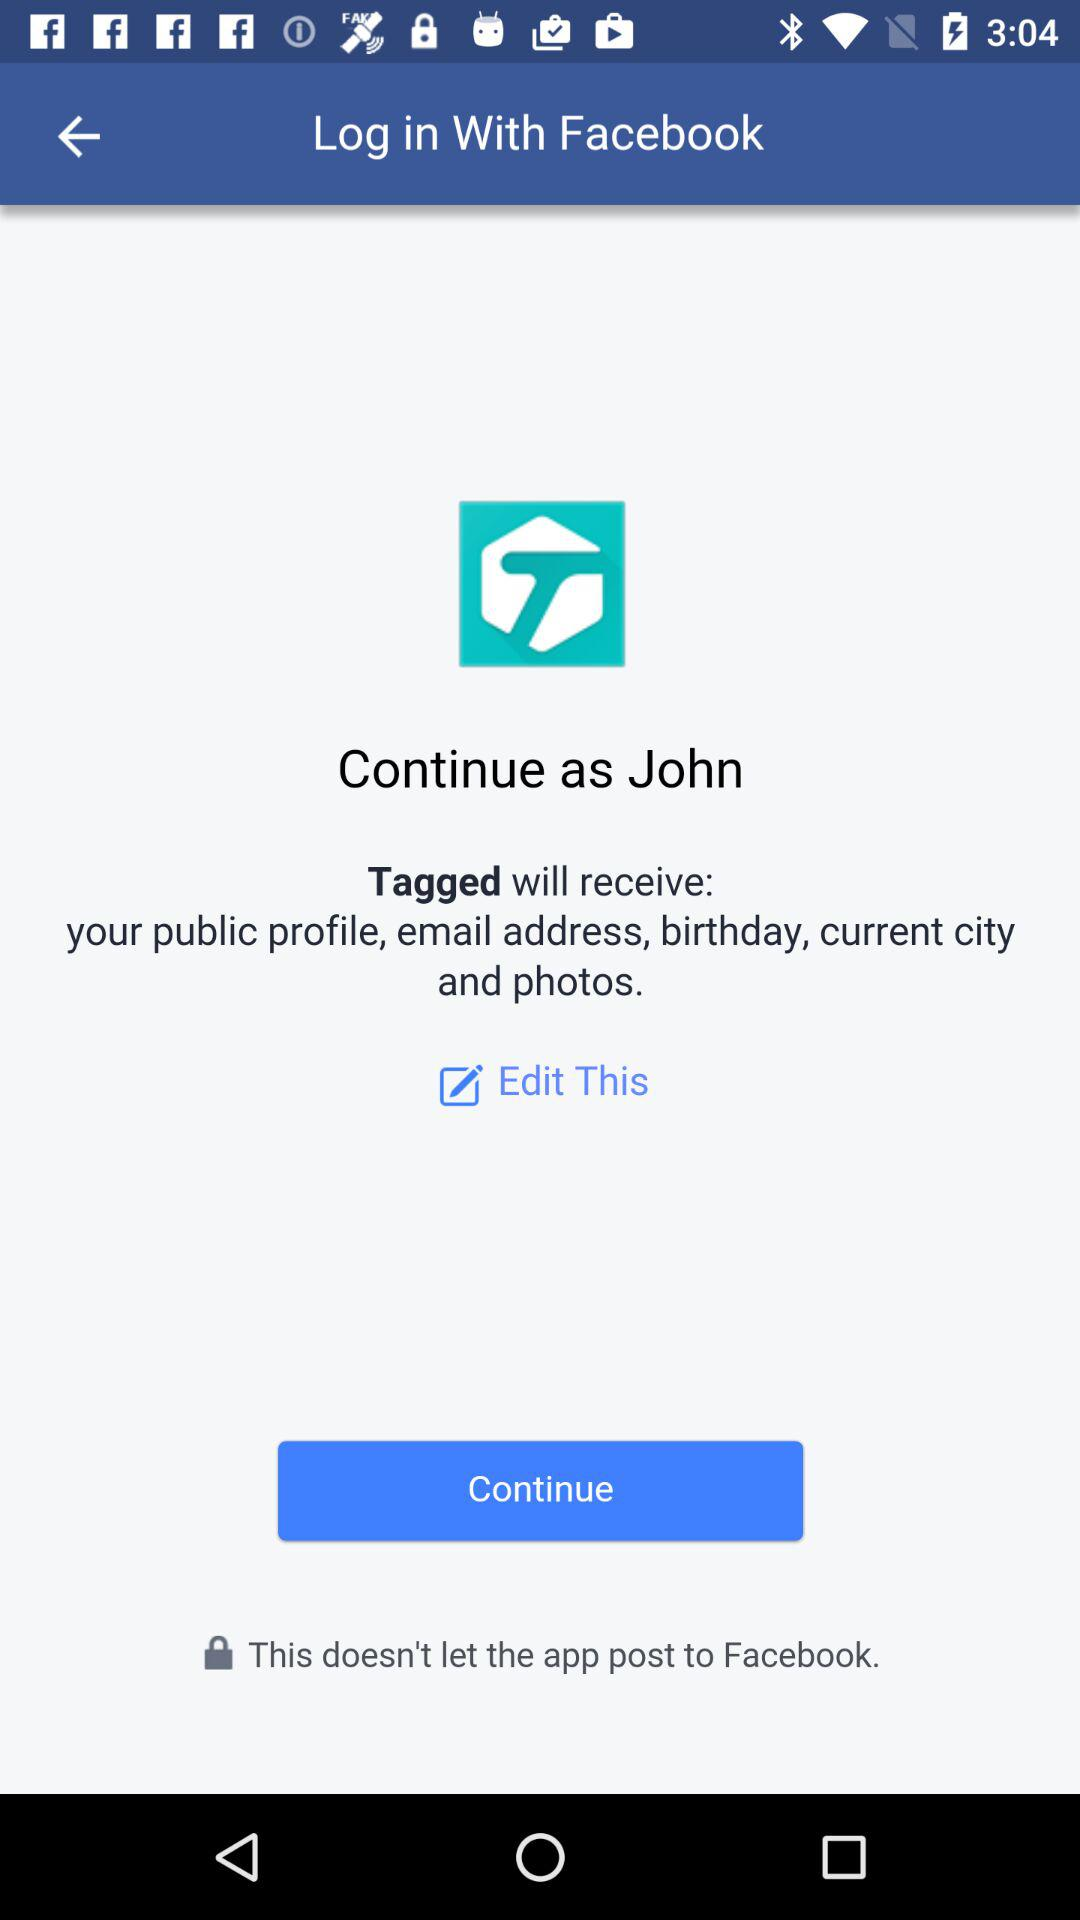What account am I using to continue? You are using "Facebook" account. 